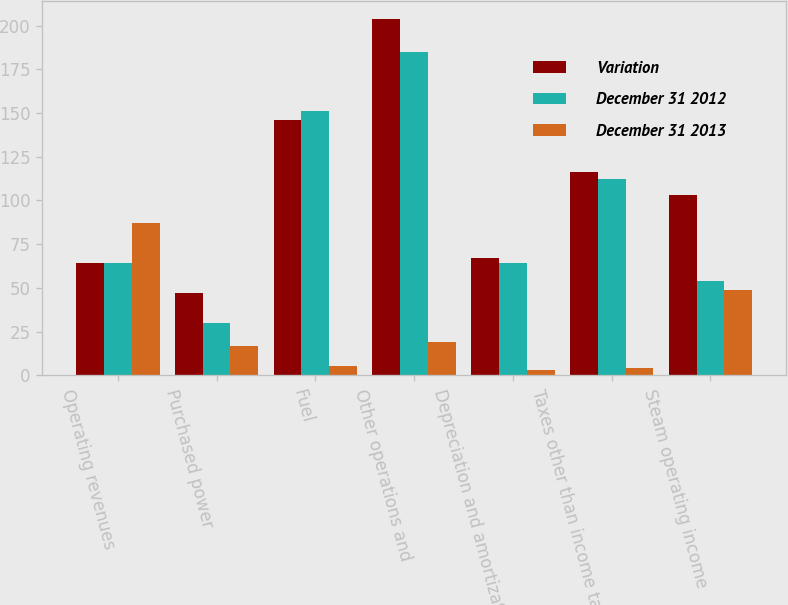<chart> <loc_0><loc_0><loc_500><loc_500><stacked_bar_chart><ecel><fcel>Operating revenues<fcel>Purchased power<fcel>Fuel<fcel>Other operations and<fcel>Depreciation and amortization<fcel>Taxes other than income taxes<fcel>Steam operating income<nl><fcel>Variation<fcel>64<fcel>47<fcel>146<fcel>204<fcel>67<fcel>116<fcel>103<nl><fcel>December 31 2012<fcel>64<fcel>30<fcel>151<fcel>185<fcel>64<fcel>112<fcel>54<nl><fcel>December 31 2013<fcel>87<fcel>17<fcel>5<fcel>19<fcel>3<fcel>4<fcel>49<nl></chart> 